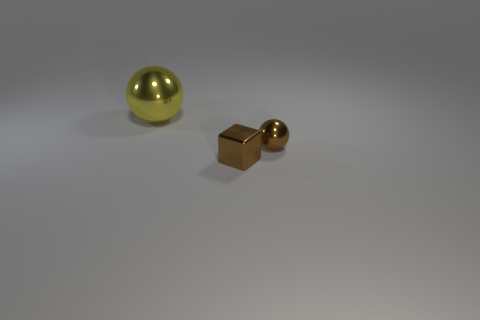How many yellow objects are shiny blocks or small balls?
Provide a short and direct response. 0. There is a small object that is on the right side of the tiny brown block; does it have the same shape as the yellow thing?
Give a very brief answer. Yes. Is the number of brown shiny objects that are right of the large yellow sphere greater than the number of brown balls?
Provide a succinct answer. Yes. What number of blue spheres are the same size as the brown ball?
Offer a terse response. 0. How many objects are brown balls or metal spheres in front of the yellow sphere?
Offer a terse response. 1. There is a object that is in front of the large yellow ball and behind the tiny cube; what color is it?
Give a very brief answer. Brown. Do the yellow sphere and the brown cube have the same size?
Your answer should be compact. No. What is the color of the ball that is in front of the yellow ball?
Give a very brief answer. Brown. Is there a tiny metallic block of the same color as the small sphere?
Keep it short and to the point. Yes. There is a metallic thing that is the same size as the brown cube; what color is it?
Keep it short and to the point. Brown. 